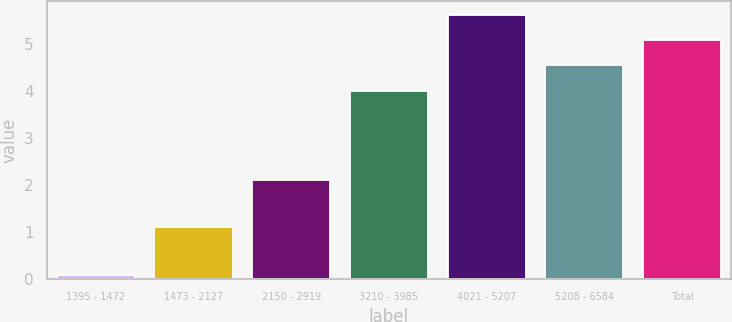Convert chart to OTSL. <chart><loc_0><loc_0><loc_500><loc_500><bar_chart><fcel>1395 - 1472<fcel>1473 - 2127<fcel>2150 - 2919<fcel>3210 - 3985<fcel>4021 - 5207<fcel>5208 - 6584<fcel>Total<nl><fcel>0.1<fcel>1.1<fcel>2.1<fcel>4<fcel>5.62<fcel>4.54<fcel>5.08<nl></chart> 